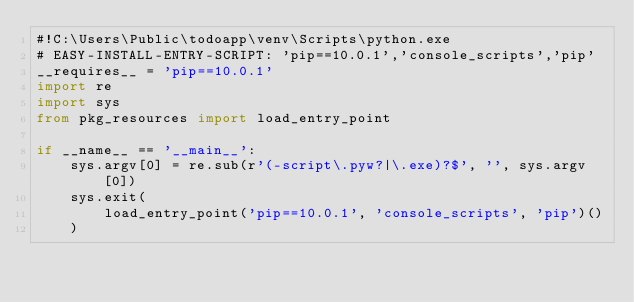<code> <loc_0><loc_0><loc_500><loc_500><_Python_>#!C:\Users\Public\todoapp\venv\Scripts\python.exe
# EASY-INSTALL-ENTRY-SCRIPT: 'pip==10.0.1','console_scripts','pip'
__requires__ = 'pip==10.0.1'
import re
import sys
from pkg_resources import load_entry_point

if __name__ == '__main__':
    sys.argv[0] = re.sub(r'(-script\.pyw?|\.exe)?$', '', sys.argv[0])
    sys.exit(
        load_entry_point('pip==10.0.1', 'console_scripts', 'pip')()
    )
</code> 